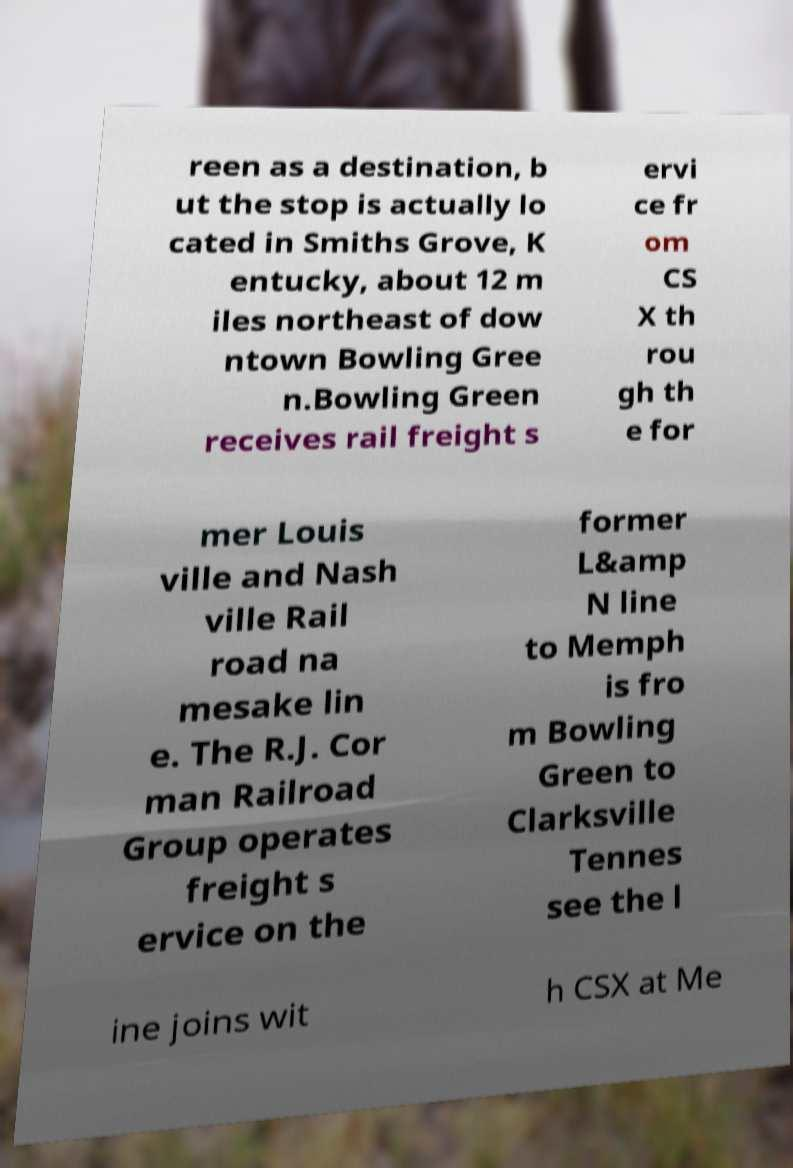There's text embedded in this image that I need extracted. Can you transcribe it verbatim? reen as a destination, b ut the stop is actually lo cated in Smiths Grove, K entucky, about 12 m iles northeast of dow ntown Bowling Gree n.Bowling Green receives rail freight s ervi ce fr om CS X th rou gh th e for mer Louis ville and Nash ville Rail road na mesake lin e. The R.J. Cor man Railroad Group operates freight s ervice on the former L&amp N line to Memph is fro m Bowling Green to Clarksville Tennes see the l ine joins wit h CSX at Me 